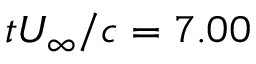Convert formula to latex. <formula><loc_0><loc_0><loc_500><loc_500>t U _ { \infty } / c = 7 . 0 0</formula> 